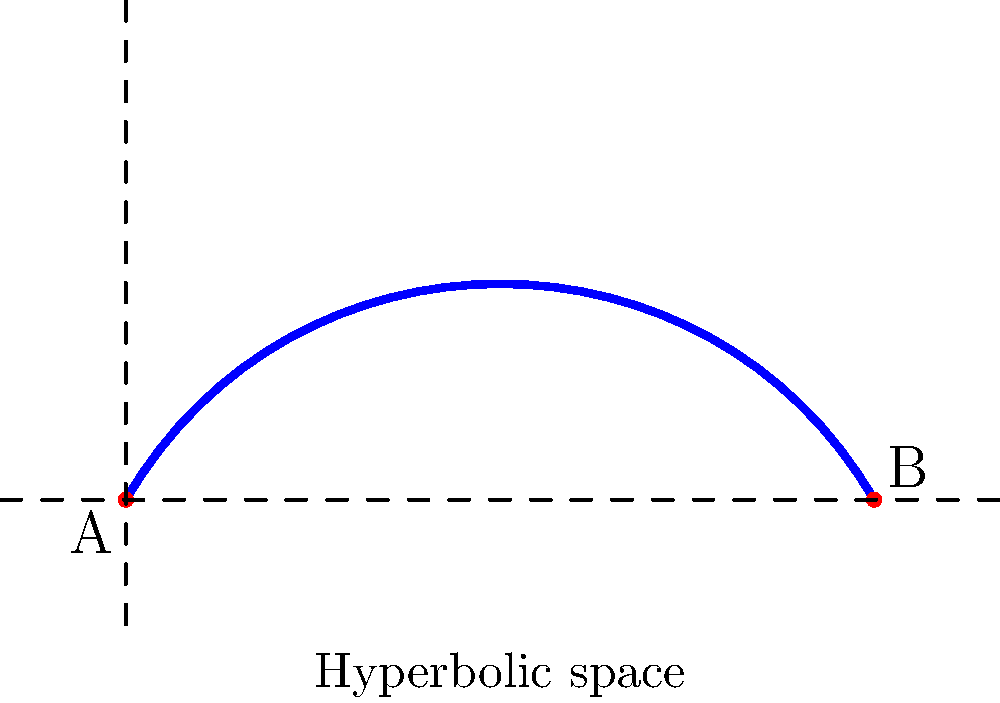In a hyperbolic space represented by a saddle-shaped surface, two points A and B are connected by a geodesic as shown in the figure. If the intrinsic distance along this geodesic is measured to be 5 units, what would be the Euclidean distance between these points if projected onto a flat plane? Assume the curvature of the hyperbolic space is constant with a value of $K = -1$ $\text{m}^{-2}$. To solve this problem, we need to follow these steps:

1) In hyperbolic geometry, the relation between the intrinsic distance $s$ along a geodesic and the Euclidean distance $x$ when projected onto a flat plane is given by:

   $$x = \frac{1}{\sqrt{|K|}} \cdot \text{arcosh}(\cosh(\sqrt{|K|}s))$$

   Where $K$ is the curvature of the hyperbolic space.

2) We are given:
   - Intrinsic distance $s = 5$ units
   - Curvature $K = -1$ $\text{m}^{-2}$

3) Substituting these values into the equation:

   $$x = \frac{1}{\sqrt{|-1|}} \cdot \text{arcosh}(\cosh(\sqrt{|-1|} \cdot 5))$$

4) Simplify:
   
   $$x = 1 \cdot \text{arcosh}(\cosh(5))$$

5) Calculate:
   
   $$x = \text{arcosh}(\cosh(5)) \approx 4.31$$

6) The Euclidean distance is approximately 4.31 units.

This result shows that in hyperbolic space, the Euclidean distance between two points when projected onto a flat plane is always less than the intrinsic distance along the geodesic connecting those points.
Answer: 4.31 units 